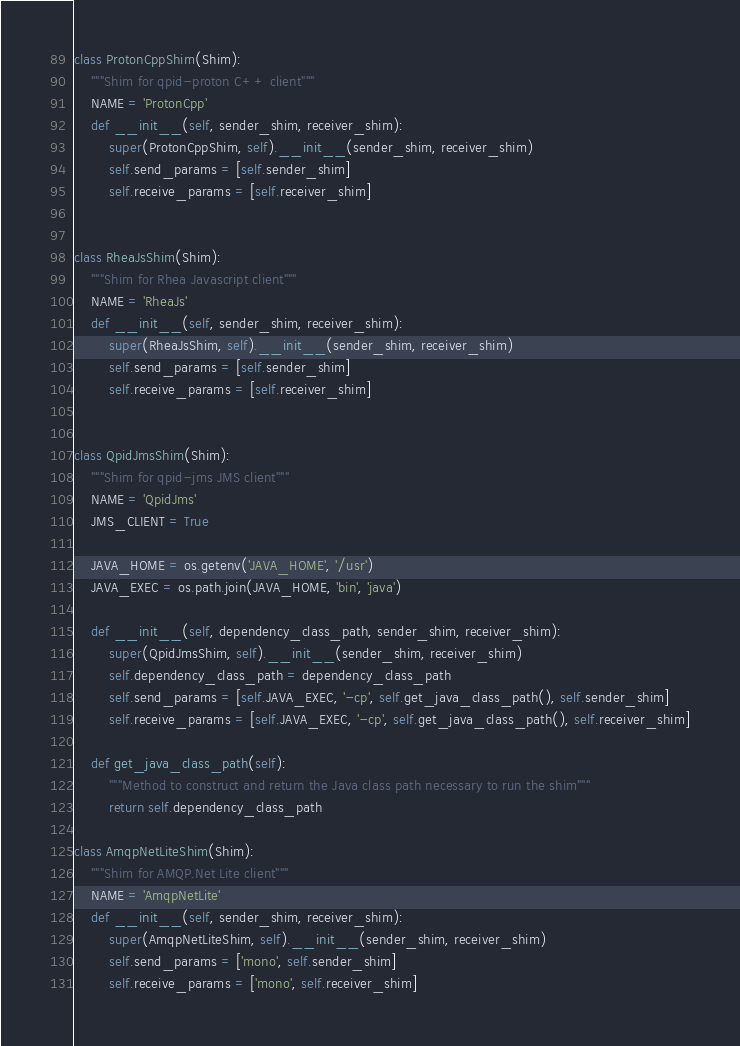Convert code to text. <code><loc_0><loc_0><loc_500><loc_500><_Python_>

class ProtonCppShim(Shim):
    """Shim for qpid-proton C++ client"""
    NAME = 'ProtonCpp'
    def __init__(self, sender_shim, receiver_shim):
        super(ProtonCppShim, self).__init__(sender_shim, receiver_shim)
        self.send_params = [self.sender_shim]
        self.receive_params = [self.receiver_shim]


class RheaJsShim(Shim):
    """Shim for Rhea Javascript client"""
    NAME = 'RheaJs'
    def __init__(self, sender_shim, receiver_shim):
        super(RheaJsShim, self).__init__(sender_shim, receiver_shim)
        self.send_params = [self.sender_shim]
        self.receive_params = [self.receiver_shim]


class QpidJmsShim(Shim):
    """Shim for qpid-jms JMS client"""
    NAME = 'QpidJms'
    JMS_CLIENT = True

    JAVA_HOME = os.getenv('JAVA_HOME', '/usr')
    JAVA_EXEC = os.path.join(JAVA_HOME, 'bin', 'java')

    def __init__(self, dependency_class_path, sender_shim, receiver_shim):
        super(QpidJmsShim, self).__init__(sender_shim, receiver_shim)
        self.dependency_class_path = dependency_class_path
        self.send_params = [self.JAVA_EXEC, '-cp', self.get_java_class_path(), self.sender_shim]
        self.receive_params = [self.JAVA_EXEC, '-cp', self.get_java_class_path(), self.receiver_shim]

    def get_java_class_path(self):
        """Method to construct and return the Java class path necessary to run the shim"""
        return self.dependency_class_path

class AmqpNetLiteShim(Shim):
    """Shim for AMQP.Net Lite client"""
    NAME = 'AmqpNetLite'
    def __init__(self, sender_shim, receiver_shim):
        super(AmqpNetLiteShim, self).__init__(sender_shim, receiver_shim)
        self.send_params = ['mono', self.sender_shim]
        self.receive_params = ['mono', self.receiver_shim]
</code> 